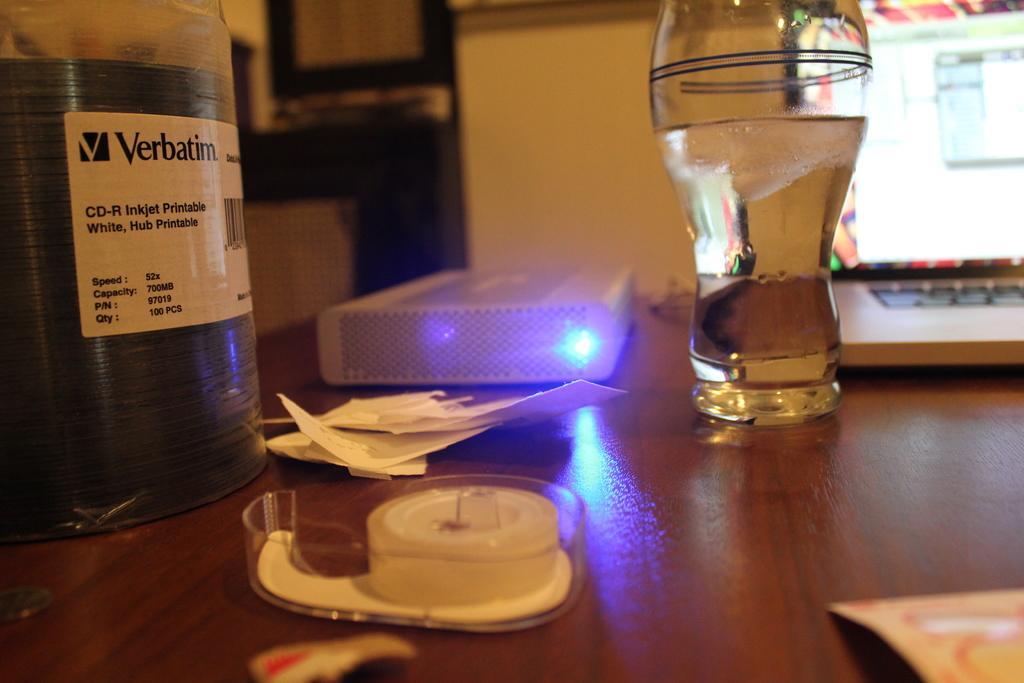Please provide a concise description of this image. In this picture we can see a glass, laptop, papers and other things on the table. 